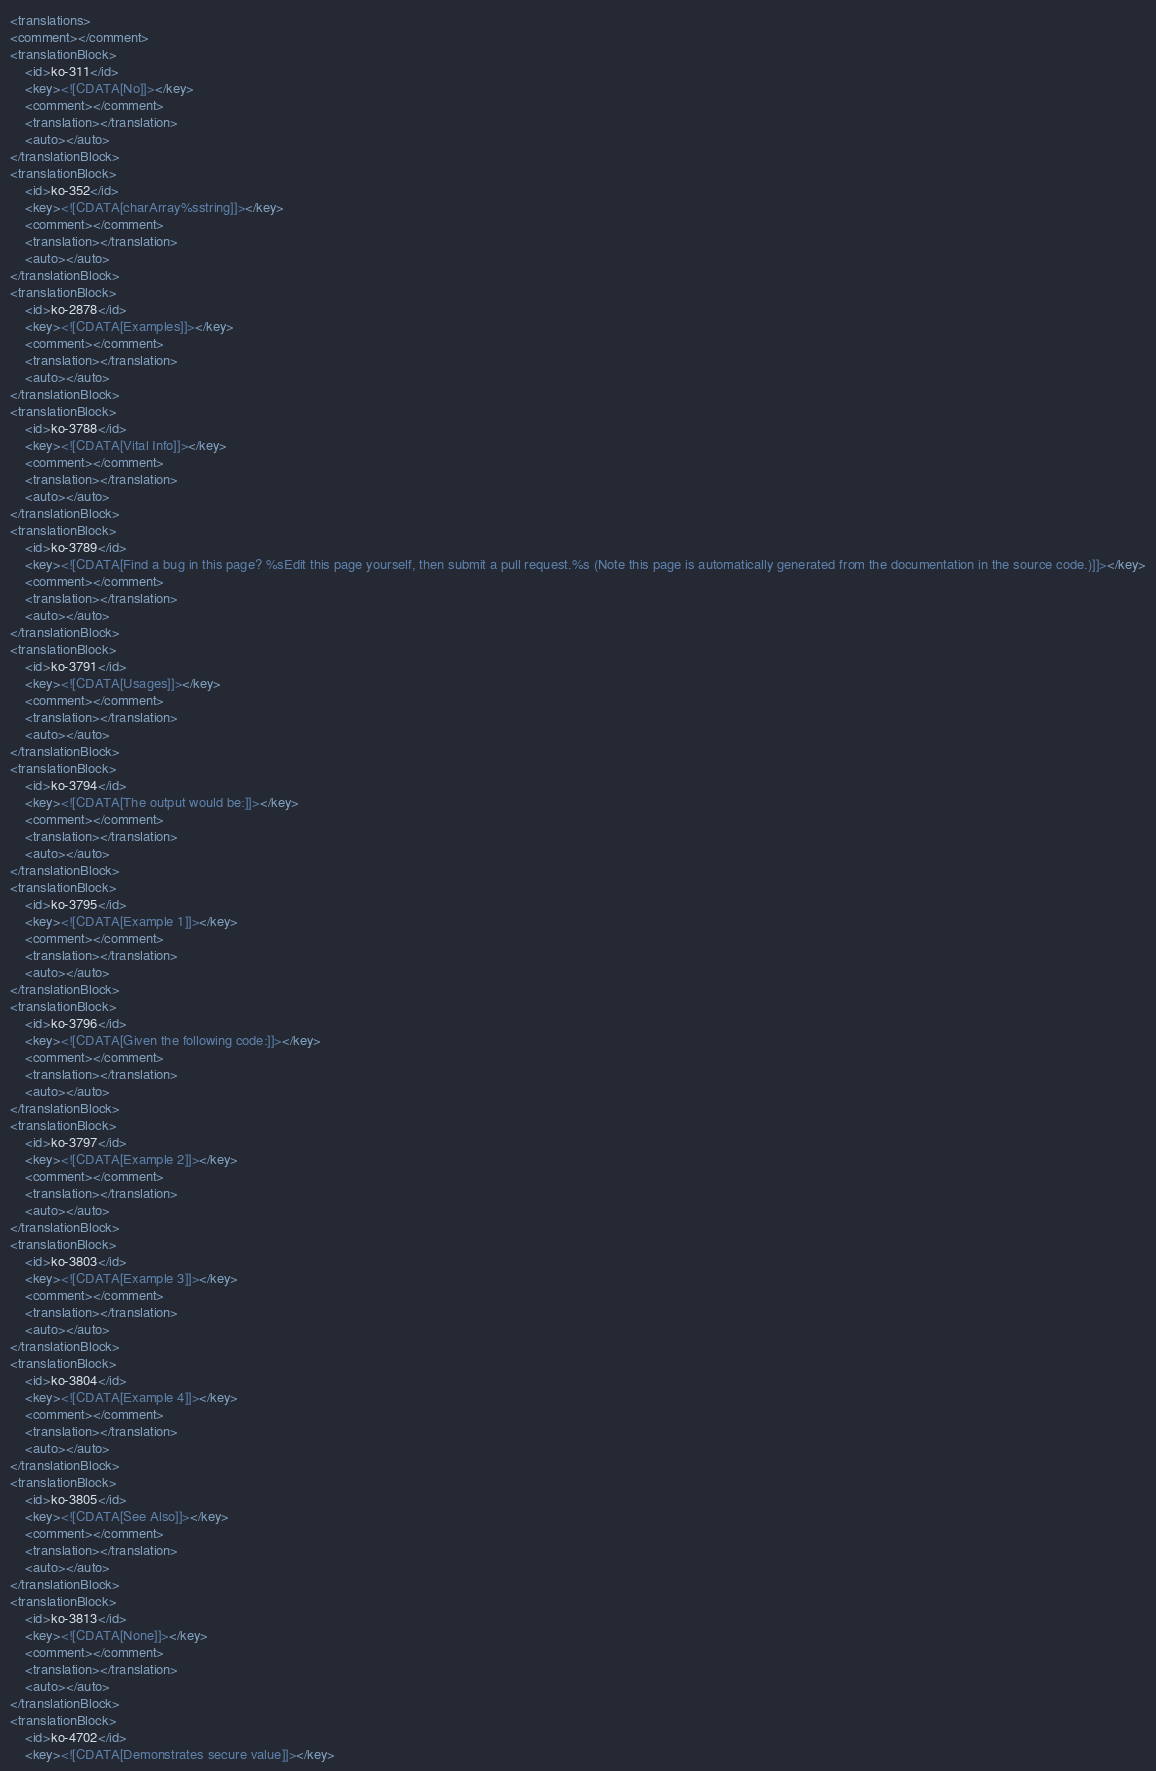<code> <loc_0><loc_0><loc_500><loc_500><_XML_><translations>
<comment></comment>
<translationBlock>
	<id>ko-311</id>
	<key><![CDATA[No]]></key>
	<comment></comment>
	<translation></translation>
	<auto></auto>
</translationBlock>
<translationBlock>
	<id>ko-352</id>
	<key><![CDATA[charArray%sstring]]></key>
	<comment></comment>
	<translation></translation>
	<auto></auto>
</translationBlock>
<translationBlock>
	<id>ko-2878</id>
	<key><![CDATA[Examples]]></key>
	<comment></comment>
	<translation></translation>
	<auto></auto>
</translationBlock>
<translationBlock>
	<id>ko-3788</id>
	<key><![CDATA[Vital Info]]></key>
	<comment></comment>
	<translation></translation>
	<auto></auto>
</translationBlock>
<translationBlock>
	<id>ko-3789</id>
	<key><![CDATA[Find a bug in this page? %sEdit this page yourself, then submit a pull request.%s (Note this page is automatically generated from the documentation in the source code.)]]></key>
	<comment></comment>
	<translation></translation>
	<auto></auto>
</translationBlock>
<translationBlock>
	<id>ko-3791</id>
	<key><![CDATA[Usages]]></key>
	<comment></comment>
	<translation></translation>
	<auto></auto>
</translationBlock>
<translationBlock>
	<id>ko-3794</id>
	<key><![CDATA[The output would be:]]></key>
	<comment></comment>
	<translation></translation>
	<auto></auto>
</translationBlock>
<translationBlock>
	<id>ko-3795</id>
	<key><![CDATA[Example 1]]></key>
	<comment></comment>
	<translation></translation>
	<auto></auto>
</translationBlock>
<translationBlock>
	<id>ko-3796</id>
	<key><![CDATA[Given the following code:]]></key>
	<comment></comment>
	<translation></translation>
	<auto></auto>
</translationBlock>
<translationBlock>
	<id>ko-3797</id>
	<key><![CDATA[Example 2]]></key>
	<comment></comment>
	<translation></translation>
	<auto></auto>
</translationBlock>
<translationBlock>
	<id>ko-3803</id>
	<key><![CDATA[Example 3]]></key>
	<comment></comment>
	<translation></translation>
	<auto></auto>
</translationBlock>
<translationBlock>
	<id>ko-3804</id>
	<key><![CDATA[Example 4]]></key>
	<comment></comment>
	<translation></translation>
	<auto></auto>
</translationBlock>
<translationBlock>
	<id>ko-3805</id>
	<key><![CDATA[See Also]]></key>
	<comment></comment>
	<translation></translation>
	<auto></auto>
</translationBlock>
<translationBlock>
	<id>ko-3813</id>
	<key><![CDATA[None]]></key>
	<comment></comment>
	<translation></translation>
	<auto></auto>
</translationBlock>
<translationBlock>
	<id>ko-4702</id>
	<key><![CDATA[Demonstrates secure value]]></key></code> 